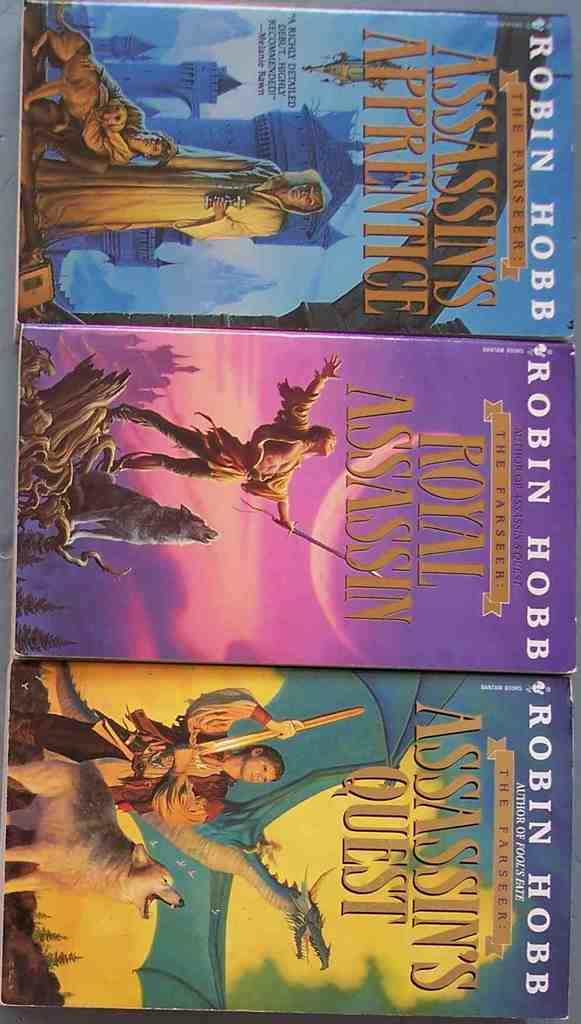<image>
Describe the image concisely. Three books by Robin Hobb placed next to one another. 